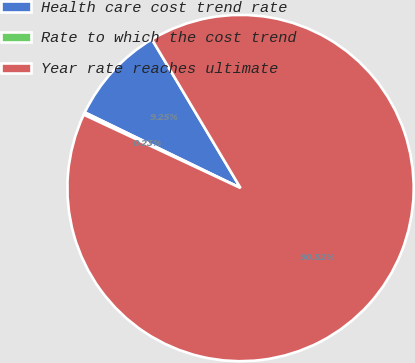Convert chart. <chart><loc_0><loc_0><loc_500><loc_500><pie_chart><fcel>Health care cost trend rate<fcel>Rate to which the cost trend<fcel>Year rate reaches ultimate<nl><fcel>9.25%<fcel>0.23%<fcel>90.52%<nl></chart> 